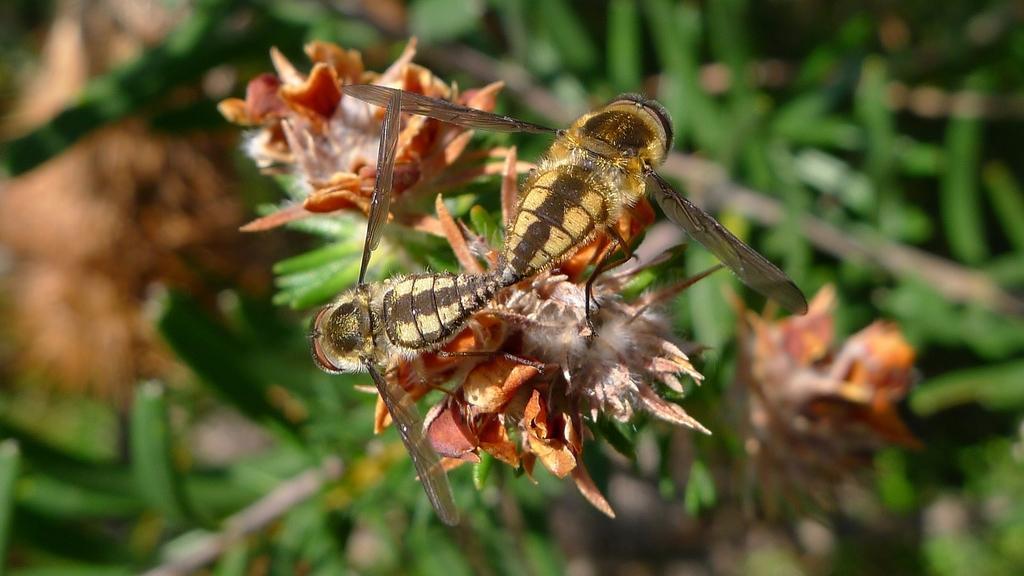Can you describe this image briefly? In this image, I can see two insects on a flower. There is a blurred background. 